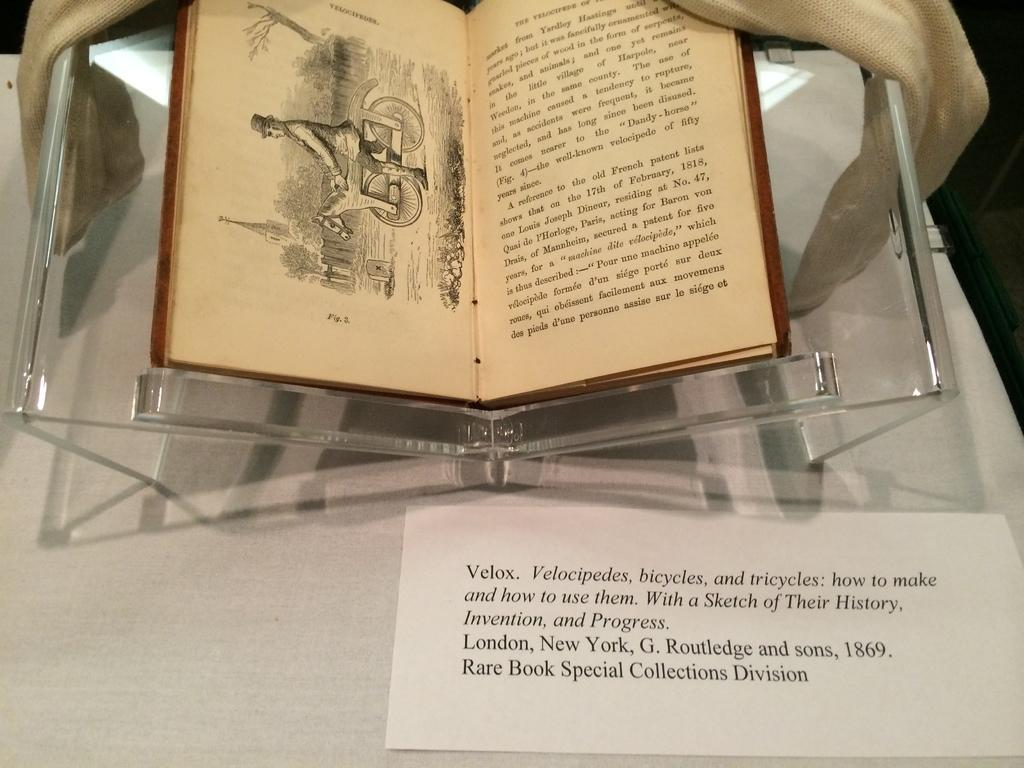<image>
Provide a brief description of the given image. A book on display is turned to an illustration and passage.  A card, titled Velox, shows that the passage regards Velocipedes, bicycles and tricycles and their history. 